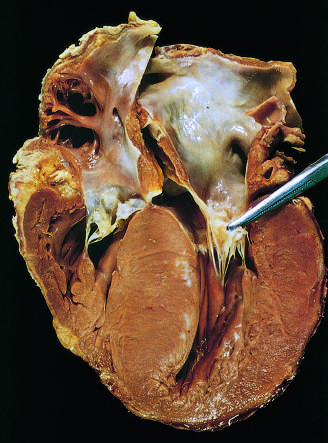does acute endocarditis bulge into the left ventricular outflow tract, giving rise to a banana-shaped ventricular lumen?
Answer the question using a single word or phrase. No 